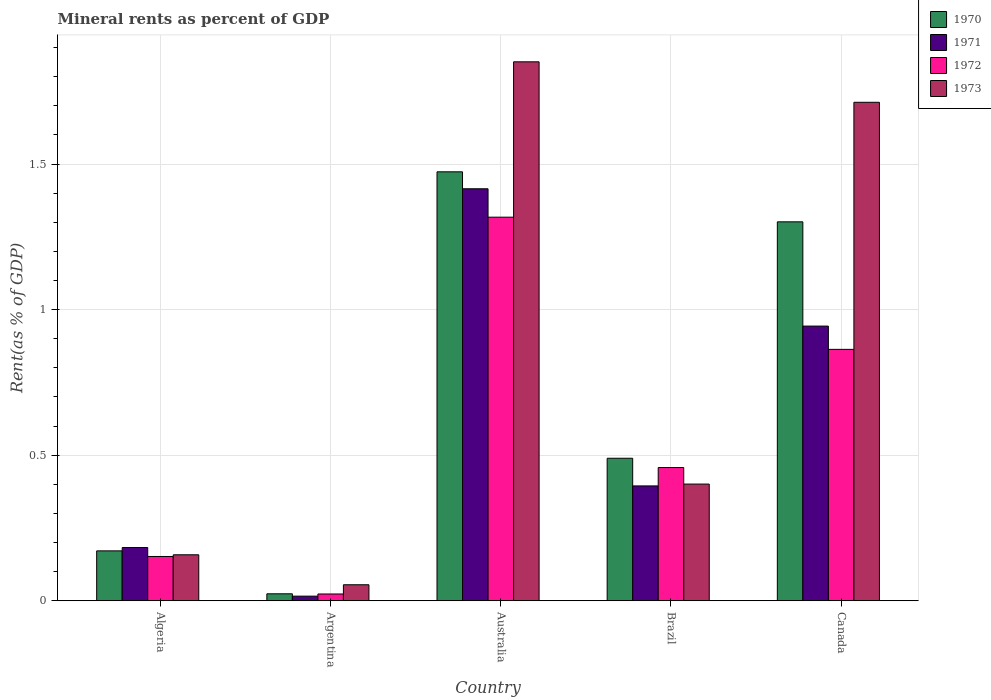Are the number of bars per tick equal to the number of legend labels?
Keep it short and to the point. Yes. Are the number of bars on each tick of the X-axis equal?
Your answer should be very brief. Yes. How many bars are there on the 2nd tick from the left?
Keep it short and to the point. 4. In how many cases, is the number of bars for a given country not equal to the number of legend labels?
Ensure brevity in your answer.  0. What is the mineral rent in 1973 in Algeria?
Your response must be concise. 0.16. Across all countries, what is the maximum mineral rent in 1970?
Provide a short and direct response. 1.47. Across all countries, what is the minimum mineral rent in 1972?
Offer a very short reply. 0.02. In which country was the mineral rent in 1972 maximum?
Offer a terse response. Australia. What is the total mineral rent in 1970 in the graph?
Offer a terse response. 3.46. What is the difference between the mineral rent in 1971 in Algeria and that in Argentina?
Offer a very short reply. 0.17. What is the difference between the mineral rent in 1971 in Australia and the mineral rent in 1970 in Argentina?
Your answer should be very brief. 1.39. What is the average mineral rent in 1972 per country?
Make the answer very short. 0.56. What is the difference between the mineral rent of/in 1971 and mineral rent of/in 1972 in Argentina?
Keep it short and to the point. -0.01. In how many countries, is the mineral rent in 1973 greater than 0.9 %?
Offer a terse response. 2. What is the ratio of the mineral rent in 1971 in Argentina to that in Canada?
Make the answer very short. 0.02. Is the mineral rent in 1971 in Australia less than that in Brazil?
Give a very brief answer. No. Is the difference between the mineral rent in 1971 in Algeria and Australia greater than the difference between the mineral rent in 1972 in Algeria and Australia?
Provide a short and direct response. No. What is the difference between the highest and the second highest mineral rent in 1972?
Keep it short and to the point. -0.45. What is the difference between the highest and the lowest mineral rent in 1971?
Provide a short and direct response. 1.4. Is the sum of the mineral rent in 1971 in Algeria and Australia greater than the maximum mineral rent in 1973 across all countries?
Ensure brevity in your answer.  No. Is it the case that in every country, the sum of the mineral rent in 1973 and mineral rent in 1971 is greater than the sum of mineral rent in 1970 and mineral rent in 1972?
Your answer should be very brief. No. What does the 1st bar from the right in Algeria represents?
Give a very brief answer. 1973. Is it the case that in every country, the sum of the mineral rent in 1971 and mineral rent in 1972 is greater than the mineral rent in 1973?
Your response must be concise. No. How many countries are there in the graph?
Provide a succinct answer. 5. Are the values on the major ticks of Y-axis written in scientific E-notation?
Your answer should be very brief. No. Does the graph contain any zero values?
Offer a very short reply. No. Does the graph contain grids?
Provide a short and direct response. Yes. What is the title of the graph?
Your response must be concise. Mineral rents as percent of GDP. Does "1986" appear as one of the legend labels in the graph?
Give a very brief answer. No. What is the label or title of the Y-axis?
Give a very brief answer. Rent(as % of GDP). What is the Rent(as % of GDP) in 1970 in Algeria?
Offer a very short reply. 0.17. What is the Rent(as % of GDP) of 1971 in Algeria?
Offer a very short reply. 0.18. What is the Rent(as % of GDP) of 1972 in Algeria?
Your answer should be compact. 0.15. What is the Rent(as % of GDP) in 1973 in Algeria?
Ensure brevity in your answer.  0.16. What is the Rent(as % of GDP) of 1970 in Argentina?
Keep it short and to the point. 0.02. What is the Rent(as % of GDP) of 1971 in Argentina?
Offer a terse response. 0.02. What is the Rent(as % of GDP) of 1972 in Argentina?
Your answer should be compact. 0.02. What is the Rent(as % of GDP) of 1973 in Argentina?
Provide a succinct answer. 0.06. What is the Rent(as % of GDP) of 1970 in Australia?
Ensure brevity in your answer.  1.47. What is the Rent(as % of GDP) of 1971 in Australia?
Give a very brief answer. 1.42. What is the Rent(as % of GDP) of 1972 in Australia?
Give a very brief answer. 1.32. What is the Rent(as % of GDP) in 1973 in Australia?
Make the answer very short. 1.85. What is the Rent(as % of GDP) of 1970 in Brazil?
Offer a very short reply. 0.49. What is the Rent(as % of GDP) of 1971 in Brazil?
Keep it short and to the point. 0.39. What is the Rent(as % of GDP) in 1972 in Brazil?
Offer a terse response. 0.46. What is the Rent(as % of GDP) of 1973 in Brazil?
Keep it short and to the point. 0.4. What is the Rent(as % of GDP) of 1970 in Canada?
Offer a very short reply. 1.3. What is the Rent(as % of GDP) of 1971 in Canada?
Your response must be concise. 0.94. What is the Rent(as % of GDP) of 1972 in Canada?
Your answer should be very brief. 0.86. What is the Rent(as % of GDP) in 1973 in Canada?
Your answer should be very brief. 1.71. Across all countries, what is the maximum Rent(as % of GDP) of 1970?
Make the answer very short. 1.47. Across all countries, what is the maximum Rent(as % of GDP) of 1971?
Give a very brief answer. 1.42. Across all countries, what is the maximum Rent(as % of GDP) of 1972?
Your answer should be compact. 1.32. Across all countries, what is the maximum Rent(as % of GDP) of 1973?
Your response must be concise. 1.85. Across all countries, what is the minimum Rent(as % of GDP) in 1970?
Offer a very short reply. 0.02. Across all countries, what is the minimum Rent(as % of GDP) in 1971?
Your answer should be very brief. 0.02. Across all countries, what is the minimum Rent(as % of GDP) of 1972?
Offer a terse response. 0.02. Across all countries, what is the minimum Rent(as % of GDP) in 1973?
Provide a short and direct response. 0.06. What is the total Rent(as % of GDP) of 1970 in the graph?
Your response must be concise. 3.46. What is the total Rent(as % of GDP) in 1971 in the graph?
Keep it short and to the point. 2.95. What is the total Rent(as % of GDP) in 1972 in the graph?
Provide a succinct answer. 2.81. What is the total Rent(as % of GDP) of 1973 in the graph?
Your answer should be compact. 4.18. What is the difference between the Rent(as % of GDP) of 1970 in Algeria and that in Argentina?
Ensure brevity in your answer.  0.15. What is the difference between the Rent(as % of GDP) in 1971 in Algeria and that in Argentina?
Your answer should be very brief. 0.17. What is the difference between the Rent(as % of GDP) of 1972 in Algeria and that in Argentina?
Keep it short and to the point. 0.13. What is the difference between the Rent(as % of GDP) of 1973 in Algeria and that in Argentina?
Your answer should be very brief. 0.1. What is the difference between the Rent(as % of GDP) in 1970 in Algeria and that in Australia?
Give a very brief answer. -1.3. What is the difference between the Rent(as % of GDP) of 1971 in Algeria and that in Australia?
Your response must be concise. -1.23. What is the difference between the Rent(as % of GDP) of 1972 in Algeria and that in Australia?
Ensure brevity in your answer.  -1.17. What is the difference between the Rent(as % of GDP) in 1973 in Algeria and that in Australia?
Your response must be concise. -1.69. What is the difference between the Rent(as % of GDP) in 1970 in Algeria and that in Brazil?
Your answer should be very brief. -0.32. What is the difference between the Rent(as % of GDP) in 1971 in Algeria and that in Brazil?
Your answer should be very brief. -0.21. What is the difference between the Rent(as % of GDP) of 1972 in Algeria and that in Brazil?
Provide a succinct answer. -0.31. What is the difference between the Rent(as % of GDP) in 1973 in Algeria and that in Brazil?
Your answer should be very brief. -0.24. What is the difference between the Rent(as % of GDP) in 1970 in Algeria and that in Canada?
Provide a succinct answer. -1.13. What is the difference between the Rent(as % of GDP) of 1971 in Algeria and that in Canada?
Give a very brief answer. -0.76. What is the difference between the Rent(as % of GDP) of 1972 in Algeria and that in Canada?
Give a very brief answer. -0.71. What is the difference between the Rent(as % of GDP) in 1973 in Algeria and that in Canada?
Your answer should be compact. -1.55. What is the difference between the Rent(as % of GDP) in 1970 in Argentina and that in Australia?
Your answer should be very brief. -1.45. What is the difference between the Rent(as % of GDP) in 1971 in Argentina and that in Australia?
Ensure brevity in your answer.  -1.4. What is the difference between the Rent(as % of GDP) in 1972 in Argentina and that in Australia?
Give a very brief answer. -1.29. What is the difference between the Rent(as % of GDP) of 1973 in Argentina and that in Australia?
Make the answer very short. -1.8. What is the difference between the Rent(as % of GDP) in 1970 in Argentina and that in Brazil?
Offer a terse response. -0.47. What is the difference between the Rent(as % of GDP) in 1971 in Argentina and that in Brazil?
Offer a terse response. -0.38. What is the difference between the Rent(as % of GDP) in 1972 in Argentina and that in Brazil?
Your response must be concise. -0.43. What is the difference between the Rent(as % of GDP) in 1973 in Argentina and that in Brazil?
Provide a short and direct response. -0.35. What is the difference between the Rent(as % of GDP) of 1970 in Argentina and that in Canada?
Give a very brief answer. -1.28. What is the difference between the Rent(as % of GDP) of 1971 in Argentina and that in Canada?
Offer a terse response. -0.93. What is the difference between the Rent(as % of GDP) of 1972 in Argentina and that in Canada?
Provide a short and direct response. -0.84. What is the difference between the Rent(as % of GDP) in 1973 in Argentina and that in Canada?
Give a very brief answer. -1.66. What is the difference between the Rent(as % of GDP) of 1970 in Australia and that in Brazil?
Ensure brevity in your answer.  0.98. What is the difference between the Rent(as % of GDP) of 1971 in Australia and that in Brazil?
Ensure brevity in your answer.  1.02. What is the difference between the Rent(as % of GDP) of 1972 in Australia and that in Brazil?
Offer a very short reply. 0.86. What is the difference between the Rent(as % of GDP) of 1973 in Australia and that in Brazil?
Provide a succinct answer. 1.45. What is the difference between the Rent(as % of GDP) of 1970 in Australia and that in Canada?
Offer a terse response. 0.17. What is the difference between the Rent(as % of GDP) of 1971 in Australia and that in Canada?
Your response must be concise. 0.47. What is the difference between the Rent(as % of GDP) of 1972 in Australia and that in Canada?
Your answer should be very brief. 0.45. What is the difference between the Rent(as % of GDP) in 1973 in Australia and that in Canada?
Provide a succinct answer. 0.14. What is the difference between the Rent(as % of GDP) of 1970 in Brazil and that in Canada?
Provide a short and direct response. -0.81. What is the difference between the Rent(as % of GDP) of 1971 in Brazil and that in Canada?
Give a very brief answer. -0.55. What is the difference between the Rent(as % of GDP) in 1972 in Brazil and that in Canada?
Make the answer very short. -0.41. What is the difference between the Rent(as % of GDP) in 1973 in Brazil and that in Canada?
Provide a short and direct response. -1.31. What is the difference between the Rent(as % of GDP) in 1970 in Algeria and the Rent(as % of GDP) in 1971 in Argentina?
Your response must be concise. 0.16. What is the difference between the Rent(as % of GDP) in 1970 in Algeria and the Rent(as % of GDP) in 1972 in Argentina?
Provide a succinct answer. 0.15. What is the difference between the Rent(as % of GDP) in 1970 in Algeria and the Rent(as % of GDP) in 1973 in Argentina?
Ensure brevity in your answer.  0.12. What is the difference between the Rent(as % of GDP) of 1971 in Algeria and the Rent(as % of GDP) of 1972 in Argentina?
Make the answer very short. 0.16. What is the difference between the Rent(as % of GDP) in 1971 in Algeria and the Rent(as % of GDP) in 1973 in Argentina?
Your answer should be very brief. 0.13. What is the difference between the Rent(as % of GDP) in 1972 in Algeria and the Rent(as % of GDP) in 1973 in Argentina?
Ensure brevity in your answer.  0.1. What is the difference between the Rent(as % of GDP) in 1970 in Algeria and the Rent(as % of GDP) in 1971 in Australia?
Make the answer very short. -1.24. What is the difference between the Rent(as % of GDP) of 1970 in Algeria and the Rent(as % of GDP) of 1972 in Australia?
Ensure brevity in your answer.  -1.15. What is the difference between the Rent(as % of GDP) in 1970 in Algeria and the Rent(as % of GDP) in 1973 in Australia?
Offer a terse response. -1.68. What is the difference between the Rent(as % of GDP) of 1971 in Algeria and the Rent(as % of GDP) of 1972 in Australia?
Keep it short and to the point. -1.13. What is the difference between the Rent(as % of GDP) in 1971 in Algeria and the Rent(as % of GDP) in 1973 in Australia?
Your answer should be very brief. -1.67. What is the difference between the Rent(as % of GDP) of 1972 in Algeria and the Rent(as % of GDP) of 1973 in Australia?
Provide a short and direct response. -1.7. What is the difference between the Rent(as % of GDP) in 1970 in Algeria and the Rent(as % of GDP) in 1971 in Brazil?
Make the answer very short. -0.22. What is the difference between the Rent(as % of GDP) of 1970 in Algeria and the Rent(as % of GDP) of 1972 in Brazil?
Provide a short and direct response. -0.29. What is the difference between the Rent(as % of GDP) of 1970 in Algeria and the Rent(as % of GDP) of 1973 in Brazil?
Keep it short and to the point. -0.23. What is the difference between the Rent(as % of GDP) of 1971 in Algeria and the Rent(as % of GDP) of 1972 in Brazil?
Your answer should be very brief. -0.27. What is the difference between the Rent(as % of GDP) of 1971 in Algeria and the Rent(as % of GDP) of 1973 in Brazil?
Your answer should be compact. -0.22. What is the difference between the Rent(as % of GDP) of 1972 in Algeria and the Rent(as % of GDP) of 1973 in Brazil?
Give a very brief answer. -0.25. What is the difference between the Rent(as % of GDP) of 1970 in Algeria and the Rent(as % of GDP) of 1971 in Canada?
Give a very brief answer. -0.77. What is the difference between the Rent(as % of GDP) in 1970 in Algeria and the Rent(as % of GDP) in 1972 in Canada?
Your answer should be very brief. -0.69. What is the difference between the Rent(as % of GDP) of 1970 in Algeria and the Rent(as % of GDP) of 1973 in Canada?
Provide a short and direct response. -1.54. What is the difference between the Rent(as % of GDP) in 1971 in Algeria and the Rent(as % of GDP) in 1972 in Canada?
Provide a short and direct response. -0.68. What is the difference between the Rent(as % of GDP) of 1971 in Algeria and the Rent(as % of GDP) of 1973 in Canada?
Give a very brief answer. -1.53. What is the difference between the Rent(as % of GDP) of 1972 in Algeria and the Rent(as % of GDP) of 1973 in Canada?
Offer a terse response. -1.56. What is the difference between the Rent(as % of GDP) in 1970 in Argentina and the Rent(as % of GDP) in 1971 in Australia?
Keep it short and to the point. -1.39. What is the difference between the Rent(as % of GDP) of 1970 in Argentina and the Rent(as % of GDP) of 1972 in Australia?
Offer a very short reply. -1.29. What is the difference between the Rent(as % of GDP) in 1970 in Argentina and the Rent(as % of GDP) in 1973 in Australia?
Offer a terse response. -1.83. What is the difference between the Rent(as % of GDP) of 1971 in Argentina and the Rent(as % of GDP) of 1972 in Australia?
Ensure brevity in your answer.  -1.3. What is the difference between the Rent(as % of GDP) of 1971 in Argentina and the Rent(as % of GDP) of 1973 in Australia?
Make the answer very short. -1.84. What is the difference between the Rent(as % of GDP) in 1972 in Argentina and the Rent(as % of GDP) in 1973 in Australia?
Offer a very short reply. -1.83. What is the difference between the Rent(as % of GDP) in 1970 in Argentina and the Rent(as % of GDP) in 1971 in Brazil?
Your answer should be very brief. -0.37. What is the difference between the Rent(as % of GDP) in 1970 in Argentina and the Rent(as % of GDP) in 1972 in Brazil?
Provide a succinct answer. -0.43. What is the difference between the Rent(as % of GDP) in 1970 in Argentina and the Rent(as % of GDP) in 1973 in Brazil?
Give a very brief answer. -0.38. What is the difference between the Rent(as % of GDP) in 1971 in Argentina and the Rent(as % of GDP) in 1972 in Brazil?
Ensure brevity in your answer.  -0.44. What is the difference between the Rent(as % of GDP) of 1971 in Argentina and the Rent(as % of GDP) of 1973 in Brazil?
Provide a short and direct response. -0.39. What is the difference between the Rent(as % of GDP) of 1972 in Argentina and the Rent(as % of GDP) of 1973 in Brazil?
Keep it short and to the point. -0.38. What is the difference between the Rent(as % of GDP) of 1970 in Argentina and the Rent(as % of GDP) of 1971 in Canada?
Your response must be concise. -0.92. What is the difference between the Rent(as % of GDP) of 1970 in Argentina and the Rent(as % of GDP) of 1972 in Canada?
Keep it short and to the point. -0.84. What is the difference between the Rent(as % of GDP) in 1970 in Argentina and the Rent(as % of GDP) in 1973 in Canada?
Keep it short and to the point. -1.69. What is the difference between the Rent(as % of GDP) of 1971 in Argentina and the Rent(as % of GDP) of 1972 in Canada?
Ensure brevity in your answer.  -0.85. What is the difference between the Rent(as % of GDP) of 1971 in Argentina and the Rent(as % of GDP) of 1973 in Canada?
Ensure brevity in your answer.  -1.7. What is the difference between the Rent(as % of GDP) of 1972 in Argentina and the Rent(as % of GDP) of 1973 in Canada?
Your response must be concise. -1.69. What is the difference between the Rent(as % of GDP) in 1970 in Australia and the Rent(as % of GDP) in 1971 in Brazil?
Provide a succinct answer. 1.08. What is the difference between the Rent(as % of GDP) of 1970 in Australia and the Rent(as % of GDP) of 1972 in Brazil?
Your response must be concise. 1.02. What is the difference between the Rent(as % of GDP) in 1970 in Australia and the Rent(as % of GDP) in 1973 in Brazil?
Your answer should be compact. 1.07. What is the difference between the Rent(as % of GDP) of 1971 in Australia and the Rent(as % of GDP) of 1972 in Brazil?
Offer a terse response. 0.96. What is the difference between the Rent(as % of GDP) in 1971 in Australia and the Rent(as % of GDP) in 1973 in Brazil?
Offer a terse response. 1.01. What is the difference between the Rent(as % of GDP) of 1972 in Australia and the Rent(as % of GDP) of 1973 in Brazil?
Offer a terse response. 0.92. What is the difference between the Rent(as % of GDP) of 1970 in Australia and the Rent(as % of GDP) of 1971 in Canada?
Provide a short and direct response. 0.53. What is the difference between the Rent(as % of GDP) of 1970 in Australia and the Rent(as % of GDP) of 1972 in Canada?
Provide a short and direct response. 0.61. What is the difference between the Rent(as % of GDP) of 1970 in Australia and the Rent(as % of GDP) of 1973 in Canada?
Give a very brief answer. -0.24. What is the difference between the Rent(as % of GDP) of 1971 in Australia and the Rent(as % of GDP) of 1972 in Canada?
Keep it short and to the point. 0.55. What is the difference between the Rent(as % of GDP) in 1971 in Australia and the Rent(as % of GDP) in 1973 in Canada?
Give a very brief answer. -0.3. What is the difference between the Rent(as % of GDP) in 1972 in Australia and the Rent(as % of GDP) in 1973 in Canada?
Keep it short and to the point. -0.39. What is the difference between the Rent(as % of GDP) in 1970 in Brazil and the Rent(as % of GDP) in 1971 in Canada?
Your answer should be very brief. -0.45. What is the difference between the Rent(as % of GDP) in 1970 in Brazil and the Rent(as % of GDP) in 1972 in Canada?
Keep it short and to the point. -0.37. What is the difference between the Rent(as % of GDP) of 1970 in Brazil and the Rent(as % of GDP) of 1973 in Canada?
Give a very brief answer. -1.22. What is the difference between the Rent(as % of GDP) in 1971 in Brazil and the Rent(as % of GDP) in 1972 in Canada?
Offer a very short reply. -0.47. What is the difference between the Rent(as % of GDP) in 1971 in Brazil and the Rent(as % of GDP) in 1973 in Canada?
Ensure brevity in your answer.  -1.32. What is the difference between the Rent(as % of GDP) in 1972 in Brazil and the Rent(as % of GDP) in 1973 in Canada?
Your answer should be compact. -1.25. What is the average Rent(as % of GDP) in 1970 per country?
Your answer should be compact. 0.69. What is the average Rent(as % of GDP) of 1971 per country?
Make the answer very short. 0.59. What is the average Rent(as % of GDP) in 1972 per country?
Provide a succinct answer. 0.56. What is the average Rent(as % of GDP) of 1973 per country?
Offer a terse response. 0.84. What is the difference between the Rent(as % of GDP) in 1970 and Rent(as % of GDP) in 1971 in Algeria?
Give a very brief answer. -0.01. What is the difference between the Rent(as % of GDP) of 1970 and Rent(as % of GDP) of 1972 in Algeria?
Provide a succinct answer. 0.02. What is the difference between the Rent(as % of GDP) of 1970 and Rent(as % of GDP) of 1973 in Algeria?
Offer a terse response. 0.01. What is the difference between the Rent(as % of GDP) in 1971 and Rent(as % of GDP) in 1972 in Algeria?
Give a very brief answer. 0.03. What is the difference between the Rent(as % of GDP) of 1971 and Rent(as % of GDP) of 1973 in Algeria?
Offer a terse response. 0.03. What is the difference between the Rent(as % of GDP) in 1972 and Rent(as % of GDP) in 1973 in Algeria?
Offer a terse response. -0.01. What is the difference between the Rent(as % of GDP) of 1970 and Rent(as % of GDP) of 1971 in Argentina?
Ensure brevity in your answer.  0.01. What is the difference between the Rent(as % of GDP) in 1970 and Rent(as % of GDP) in 1972 in Argentina?
Your answer should be very brief. 0. What is the difference between the Rent(as % of GDP) in 1970 and Rent(as % of GDP) in 1973 in Argentina?
Offer a terse response. -0.03. What is the difference between the Rent(as % of GDP) in 1971 and Rent(as % of GDP) in 1972 in Argentina?
Your answer should be compact. -0.01. What is the difference between the Rent(as % of GDP) of 1971 and Rent(as % of GDP) of 1973 in Argentina?
Provide a short and direct response. -0.04. What is the difference between the Rent(as % of GDP) of 1972 and Rent(as % of GDP) of 1973 in Argentina?
Ensure brevity in your answer.  -0.03. What is the difference between the Rent(as % of GDP) in 1970 and Rent(as % of GDP) in 1971 in Australia?
Give a very brief answer. 0.06. What is the difference between the Rent(as % of GDP) of 1970 and Rent(as % of GDP) of 1972 in Australia?
Offer a terse response. 0.16. What is the difference between the Rent(as % of GDP) of 1970 and Rent(as % of GDP) of 1973 in Australia?
Keep it short and to the point. -0.38. What is the difference between the Rent(as % of GDP) of 1971 and Rent(as % of GDP) of 1972 in Australia?
Make the answer very short. 0.1. What is the difference between the Rent(as % of GDP) in 1971 and Rent(as % of GDP) in 1973 in Australia?
Make the answer very short. -0.44. What is the difference between the Rent(as % of GDP) of 1972 and Rent(as % of GDP) of 1973 in Australia?
Your answer should be very brief. -0.53. What is the difference between the Rent(as % of GDP) in 1970 and Rent(as % of GDP) in 1971 in Brazil?
Offer a very short reply. 0.1. What is the difference between the Rent(as % of GDP) in 1970 and Rent(as % of GDP) in 1972 in Brazil?
Offer a very short reply. 0.03. What is the difference between the Rent(as % of GDP) of 1970 and Rent(as % of GDP) of 1973 in Brazil?
Your response must be concise. 0.09. What is the difference between the Rent(as % of GDP) in 1971 and Rent(as % of GDP) in 1972 in Brazil?
Provide a short and direct response. -0.06. What is the difference between the Rent(as % of GDP) of 1971 and Rent(as % of GDP) of 1973 in Brazil?
Give a very brief answer. -0.01. What is the difference between the Rent(as % of GDP) of 1972 and Rent(as % of GDP) of 1973 in Brazil?
Keep it short and to the point. 0.06. What is the difference between the Rent(as % of GDP) in 1970 and Rent(as % of GDP) in 1971 in Canada?
Give a very brief answer. 0.36. What is the difference between the Rent(as % of GDP) of 1970 and Rent(as % of GDP) of 1972 in Canada?
Provide a short and direct response. 0.44. What is the difference between the Rent(as % of GDP) in 1970 and Rent(as % of GDP) in 1973 in Canada?
Provide a succinct answer. -0.41. What is the difference between the Rent(as % of GDP) in 1971 and Rent(as % of GDP) in 1972 in Canada?
Your answer should be compact. 0.08. What is the difference between the Rent(as % of GDP) of 1971 and Rent(as % of GDP) of 1973 in Canada?
Provide a short and direct response. -0.77. What is the difference between the Rent(as % of GDP) of 1972 and Rent(as % of GDP) of 1973 in Canada?
Keep it short and to the point. -0.85. What is the ratio of the Rent(as % of GDP) in 1970 in Algeria to that in Argentina?
Give a very brief answer. 7.17. What is the ratio of the Rent(as % of GDP) in 1971 in Algeria to that in Argentina?
Your response must be concise. 11.5. What is the ratio of the Rent(as % of GDP) in 1972 in Algeria to that in Argentina?
Provide a short and direct response. 6.53. What is the ratio of the Rent(as % of GDP) in 1973 in Algeria to that in Argentina?
Your response must be concise. 2.87. What is the ratio of the Rent(as % of GDP) of 1970 in Algeria to that in Australia?
Offer a terse response. 0.12. What is the ratio of the Rent(as % of GDP) in 1971 in Algeria to that in Australia?
Provide a short and direct response. 0.13. What is the ratio of the Rent(as % of GDP) in 1972 in Algeria to that in Australia?
Your answer should be compact. 0.12. What is the ratio of the Rent(as % of GDP) of 1973 in Algeria to that in Australia?
Ensure brevity in your answer.  0.09. What is the ratio of the Rent(as % of GDP) of 1970 in Algeria to that in Brazil?
Give a very brief answer. 0.35. What is the ratio of the Rent(as % of GDP) of 1971 in Algeria to that in Brazil?
Provide a succinct answer. 0.46. What is the ratio of the Rent(as % of GDP) in 1972 in Algeria to that in Brazil?
Offer a terse response. 0.33. What is the ratio of the Rent(as % of GDP) of 1973 in Algeria to that in Brazil?
Your response must be concise. 0.39. What is the ratio of the Rent(as % of GDP) of 1970 in Algeria to that in Canada?
Ensure brevity in your answer.  0.13. What is the ratio of the Rent(as % of GDP) of 1971 in Algeria to that in Canada?
Keep it short and to the point. 0.19. What is the ratio of the Rent(as % of GDP) in 1972 in Algeria to that in Canada?
Make the answer very short. 0.18. What is the ratio of the Rent(as % of GDP) of 1973 in Algeria to that in Canada?
Your answer should be very brief. 0.09. What is the ratio of the Rent(as % of GDP) of 1970 in Argentina to that in Australia?
Offer a terse response. 0.02. What is the ratio of the Rent(as % of GDP) in 1971 in Argentina to that in Australia?
Offer a very short reply. 0.01. What is the ratio of the Rent(as % of GDP) in 1972 in Argentina to that in Australia?
Offer a very short reply. 0.02. What is the ratio of the Rent(as % of GDP) in 1973 in Argentina to that in Australia?
Provide a succinct answer. 0.03. What is the ratio of the Rent(as % of GDP) in 1970 in Argentina to that in Brazil?
Give a very brief answer. 0.05. What is the ratio of the Rent(as % of GDP) of 1971 in Argentina to that in Brazil?
Your answer should be compact. 0.04. What is the ratio of the Rent(as % of GDP) in 1972 in Argentina to that in Brazil?
Ensure brevity in your answer.  0.05. What is the ratio of the Rent(as % of GDP) in 1973 in Argentina to that in Brazil?
Your answer should be compact. 0.14. What is the ratio of the Rent(as % of GDP) in 1970 in Argentina to that in Canada?
Provide a succinct answer. 0.02. What is the ratio of the Rent(as % of GDP) in 1971 in Argentina to that in Canada?
Offer a very short reply. 0.02. What is the ratio of the Rent(as % of GDP) of 1972 in Argentina to that in Canada?
Your answer should be compact. 0.03. What is the ratio of the Rent(as % of GDP) of 1973 in Argentina to that in Canada?
Provide a succinct answer. 0.03. What is the ratio of the Rent(as % of GDP) of 1970 in Australia to that in Brazil?
Provide a short and direct response. 3.01. What is the ratio of the Rent(as % of GDP) in 1971 in Australia to that in Brazil?
Make the answer very short. 3.59. What is the ratio of the Rent(as % of GDP) of 1972 in Australia to that in Brazil?
Your response must be concise. 2.88. What is the ratio of the Rent(as % of GDP) of 1973 in Australia to that in Brazil?
Provide a succinct answer. 4.62. What is the ratio of the Rent(as % of GDP) of 1970 in Australia to that in Canada?
Ensure brevity in your answer.  1.13. What is the ratio of the Rent(as % of GDP) in 1971 in Australia to that in Canada?
Make the answer very short. 1.5. What is the ratio of the Rent(as % of GDP) in 1972 in Australia to that in Canada?
Offer a terse response. 1.53. What is the ratio of the Rent(as % of GDP) in 1973 in Australia to that in Canada?
Give a very brief answer. 1.08. What is the ratio of the Rent(as % of GDP) in 1970 in Brazil to that in Canada?
Offer a very short reply. 0.38. What is the ratio of the Rent(as % of GDP) in 1971 in Brazil to that in Canada?
Your response must be concise. 0.42. What is the ratio of the Rent(as % of GDP) in 1972 in Brazil to that in Canada?
Your response must be concise. 0.53. What is the ratio of the Rent(as % of GDP) in 1973 in Brazil to that in Canada?
Keep it short and to the point. 0.23. What is the difference between the highest and the second highest Rent(as % of GDP) in 1970?
Make the answer very short. 0.17. What is the difference between the highest and the second highest Rent(as % of GDP) in 1971?
Make the answer very short. 0.47. What is the difference between the highest and the second highest Rent(as % of GDP) of 1972?
Make the answer very short. 0.45. What is the difference between the highest and the second highest Rent(as % of GDP) in 1973?
Keep it short and to the point. 0.14. What is the difference between the highest and the lowest Rent(as % of GDP) in 1970?
Ensure brevity in your answer.  1.45. What is the difference between the highest and the lowest Rent(as % of GDP) of 1971?
Keep it short and to the point. 1.4. What is the difference between the highest and the lowest Rent(as % of GDP) of 1972?
Ensure brevity in your answer.  1.29. What is the difference between the highest and the lowest Rent(as % of GDP) in 1973?
Give a very brief answer. 1.8. 